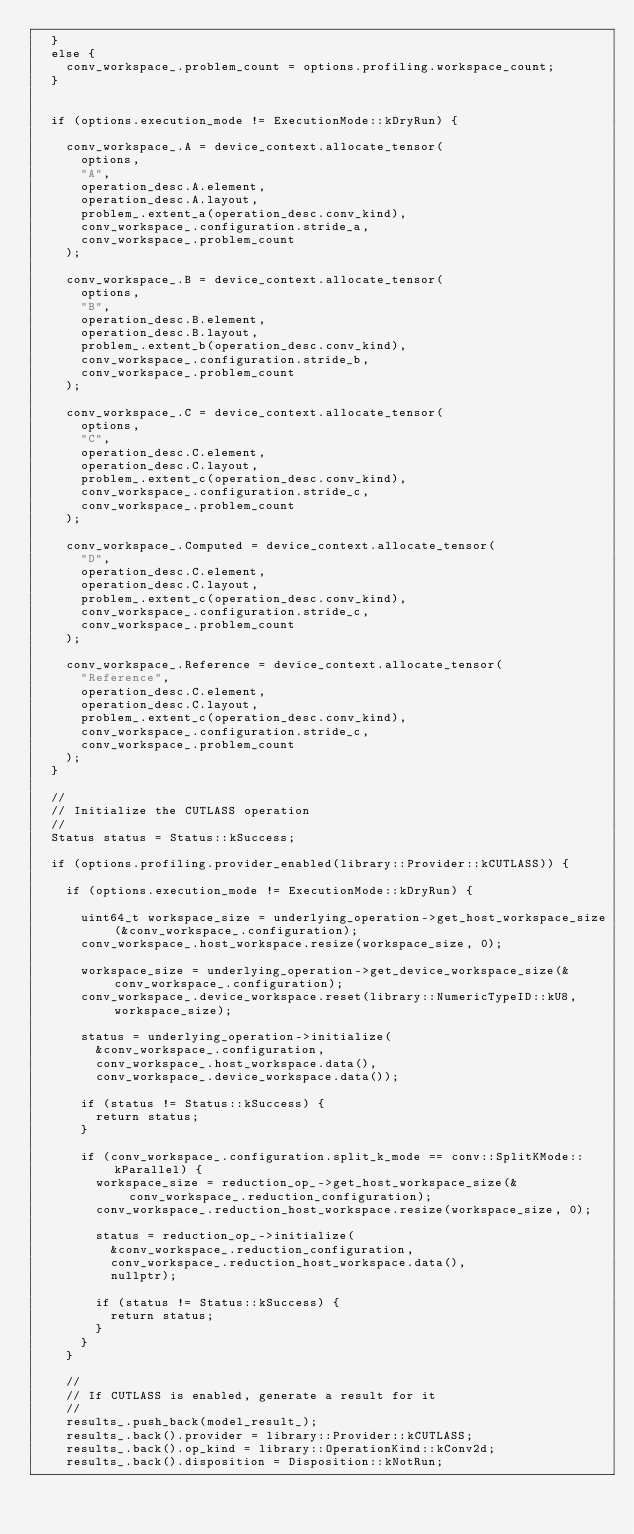<code> <loc_0><loc_0><loc_500><loc_500><_Cuda_>  }
  else {
    conv_workspace_.problem_count = options.profiling.workspace_count;
  }


  if (options.execution_mode != ExecutionMode::kDryRun) {

    conv_workspace_.A = device_context.allocate_tensor(
      options,
      "A",
      operation_desc.A.element,
      operation_desc.A.layout,
      problem_.extent_a(operation_desc.conv_kind),
      conv_workspace_.configuration.stride_a,
      conv_workspace_.problem_count
    );

    conv_workspace_.B = device_context.allocate_tensor(
      options,
      "B",
      operation_desc.B.element,
      operation_desc.B.layout,
      problem_.extent_b(operation_desc.conv_kind),
      conv_workspace_.configuration.stride_b,
      conv_workspace_.problem_count
    );

    conv_workspace_.C = device_context.allocate_tensor(
      options,
      "C",
      operation_desc.C.element,
      operation_desc.C.layout,
      problem_.extent_c(operation_desc.conv_kind),
      conv_workspace_.configuration.stride_c,
      conv_workspace_.problem_count
    );

    conv_workspace_.Computed = device_context.allocate_tensor(
      "D",
      operation_desc.C.element,
      operation_desc.C.layout,
      problem_.extent_c(operation_desc.conv_kind),
      conv_workspace_.configuration.stride_c,
      conv_workspace_.problem_count
    );

    conv_workspace_.Reference = device_context.allocate_tensor(
      "Reference",
      operation_desc.C.element,
      operation_desc.C.layout,
      problem_.extent_c(operation_desc.conv_kind),
      conv_workspace_.configuration.stride_c,
      conv_workspace_.problem_count
    );
  }

  //
  // Initialize the CUTLASS operation
  //
  Status status = Status::kSuccess;

  if (options.profiling.provider_enabled(library::Provider::kCUTLASS)) {

    if (options.execution_mode != ExecutionMode::kDryRun) {

      uint64_t workspace_size = underlying_operation->get_host_workspace_size(&conv_workspace_.configuration);
      conv_workspace_.host_workspace.resize(workspace_size, 0);

      workspace_size = underlying_operation->get_device_workspace_size(&conv_workspace_.configuration);
      conv_workspace_.device_workspace.reset(library::NumericTypeID::kU8, workspace_size);

      status = underlying_operation->initialize(
        &conv_workspace_.configuration,
        conv_workspace_.host_workspace.data(),
        conv_workspace_.device_workspace.data());

      if (status != Status::kSuccess) {
        return status;
      }

      if (conv_workspace_.configuration.split_k_mode == conv::SplitKMode::kParallel) {
        workspace_size = reduction_op_->get_host_workspace_size(&conv_workspace_.reduction_configuration);
        conv_workspace_.reduction_host_workspace.resize(workspace_size, 0);

        status = reduction_op_->initialize(
          &conv_workspace_.reduction_configuration, 
          conv_workspace_.reduction_host_workspace.data(), 
          nullptr);
        
        if (status != Status::kSuccess) {
          return status;
        }
      }
    }

    //
    // If CUTLASS is enabled, generate a result for it
    //
    results_.push_back(model_result_);
    results_.back().provider = library::Provider::kCUTLASS;
    results_.back().op_kind = library::OperationKind::kConv2d;
    results_.back().disposition = Disposition::kNotRun;
</code> 